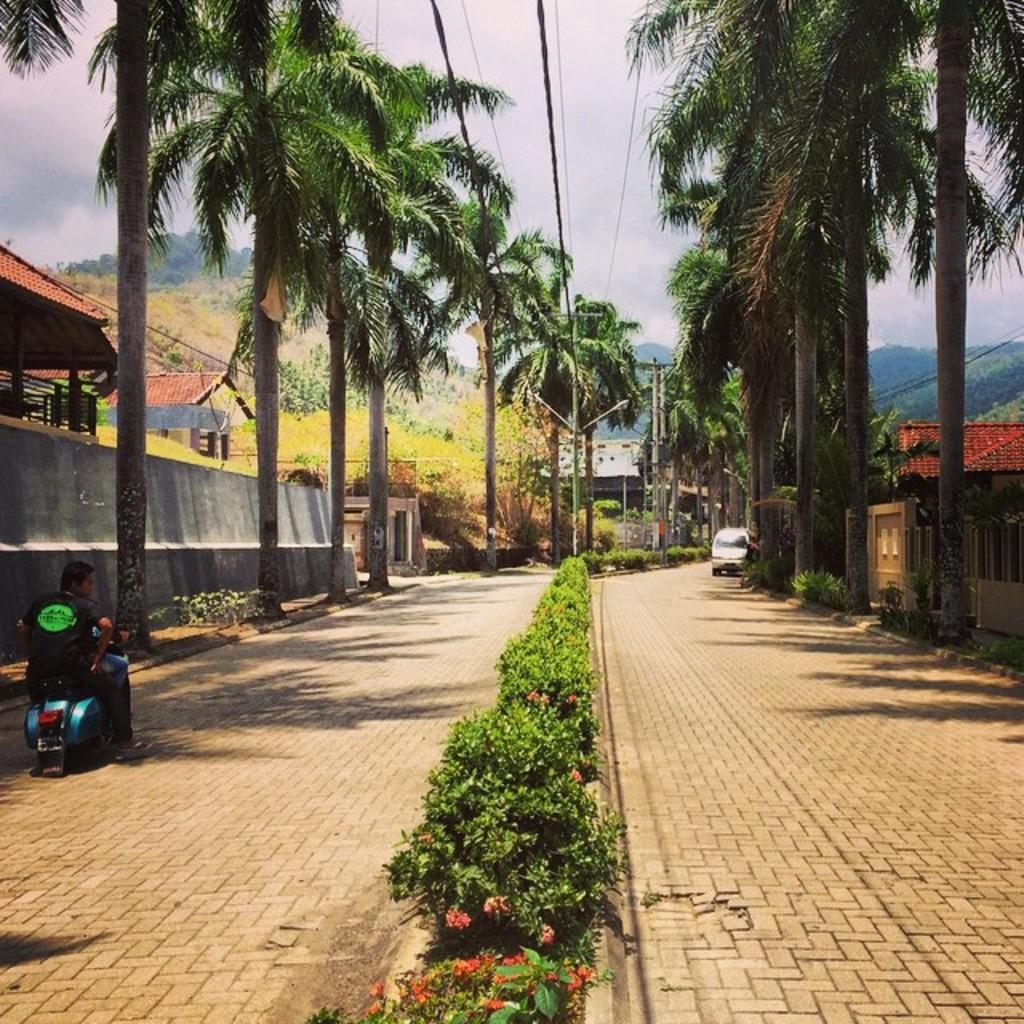In one or two sentences, can you explain what this image depicts? In the picture I can see plants on the divider, I can see a scooter on which two persons are sitting is moving on the road and they are on the left side of the image. On the right side of the image we can see a vehicle is moving on the road. On the either side of the image, we can see trees, houses, hills, wires and the sky in the background. 